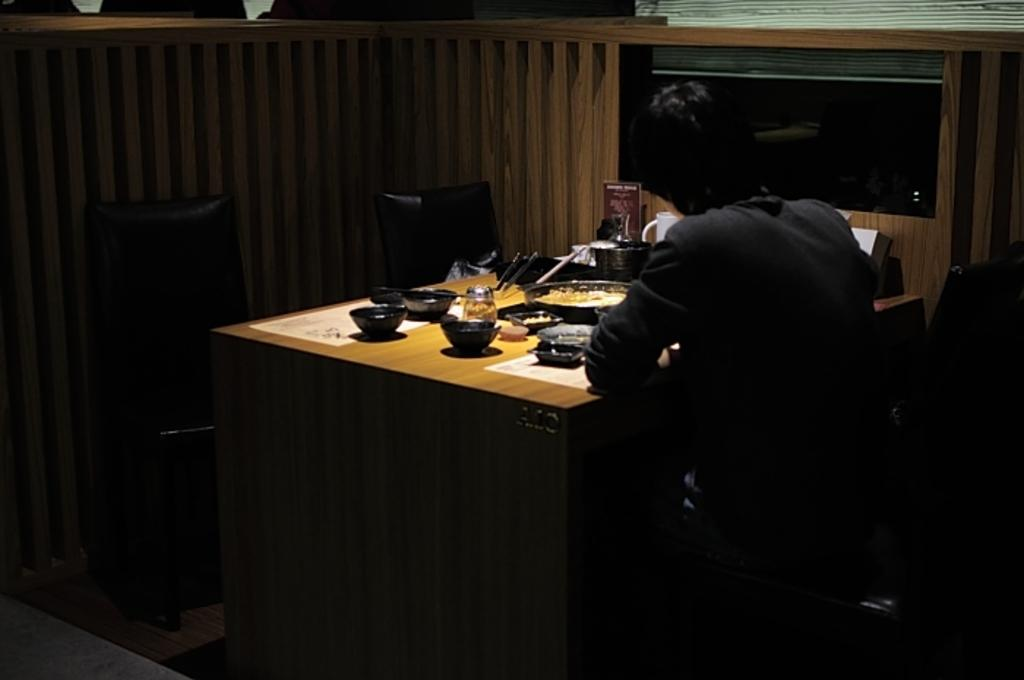What is the man in the image doing? The man is sitting on a chair in the image. What is in front of the man? There is a table in front of the man. What items can be seen on the table? There are bowls, a plate, and glasses on the table. How many people are in the crowd surrounding the man in the image? There is no crowd present in the image; it only shows a man sitting on a chair with a table in front of him. What type of art can be seen on the plate in the image? There is no art visible on the plate in the image; it is a plain plate with no decorations. 